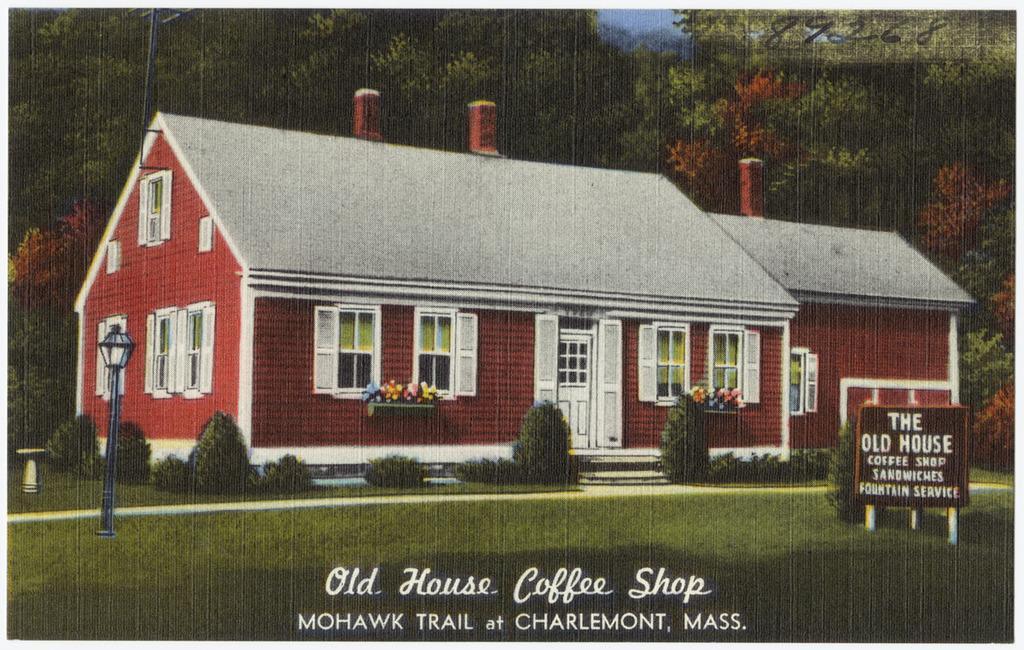Can you describe this image briefly? In this picture we can see a text on a board visible on the poles. There is some text visible at the bottom of the picture. Some grass is visible on the ground. We can see some flower pots and a few windows on a house. Few trees are visible in the background. Sky is blue in color. 